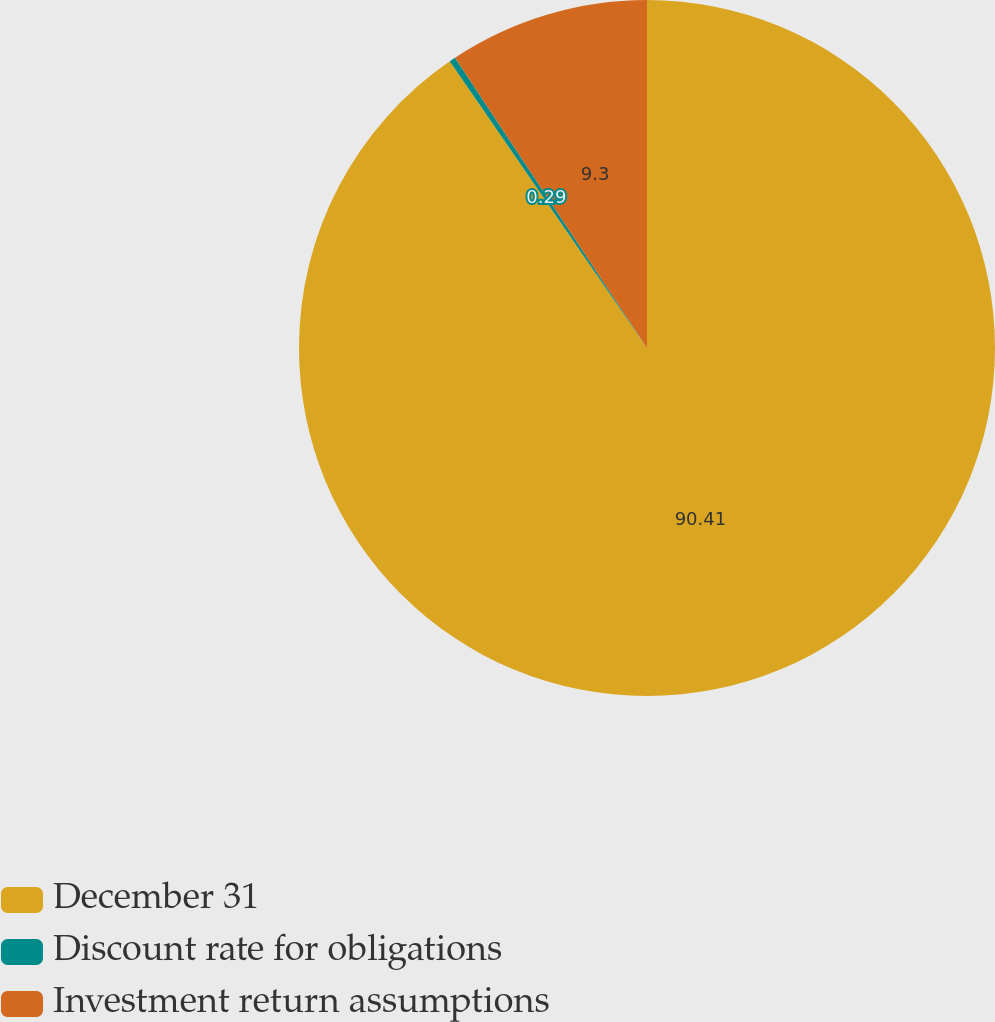Convert chart to OTSL. <chart><loc_0><loc_0><loc_500><loc_500><pie_chart><fcel>December 31<fcel>Discount rate for obligations<fcel>Investment return assumptions<nl><fcel>90.4%<fcel>0.29%<fcel>9.3%<nl></chart> 